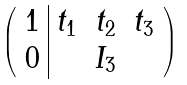<formula> <loc_0><loc_0><loc_500><loc_500>\left ( \begin{array} { c | c c c } 1 & t _ { 1 } & t _ { 2 } & t _ { 3 } \\ 0 & & I _ { 3 } & \end{array} \right )</formula> 